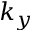Convert formula to latex. <formula><loc_0><loc_0><loc_500><loc_500>k _ { y }</formula> 